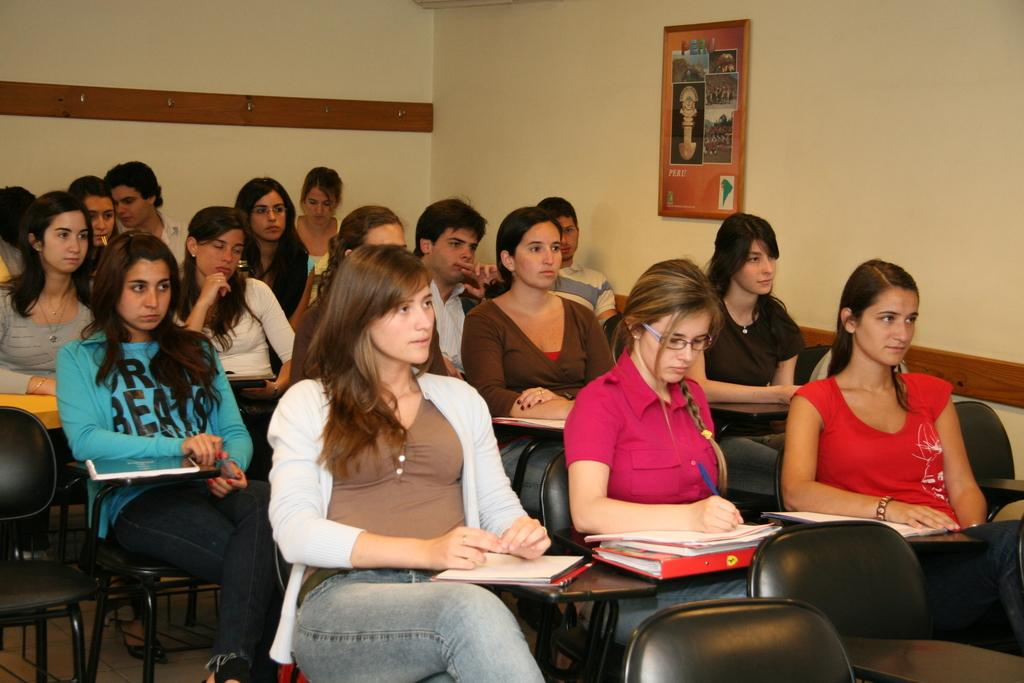What are the people in the image doing? The people in the image are sitting on chairs. What can be seen on the wall in the image? There is a poster on a wall in the image. What objects are on the table in the image? There are books on a table in the image. What is the woman holding in the image? The woman is holding a pen in the image. What type of cabbage is being used as a table in the image? There is no cabbage present in the image, and it is not being used as a table. 